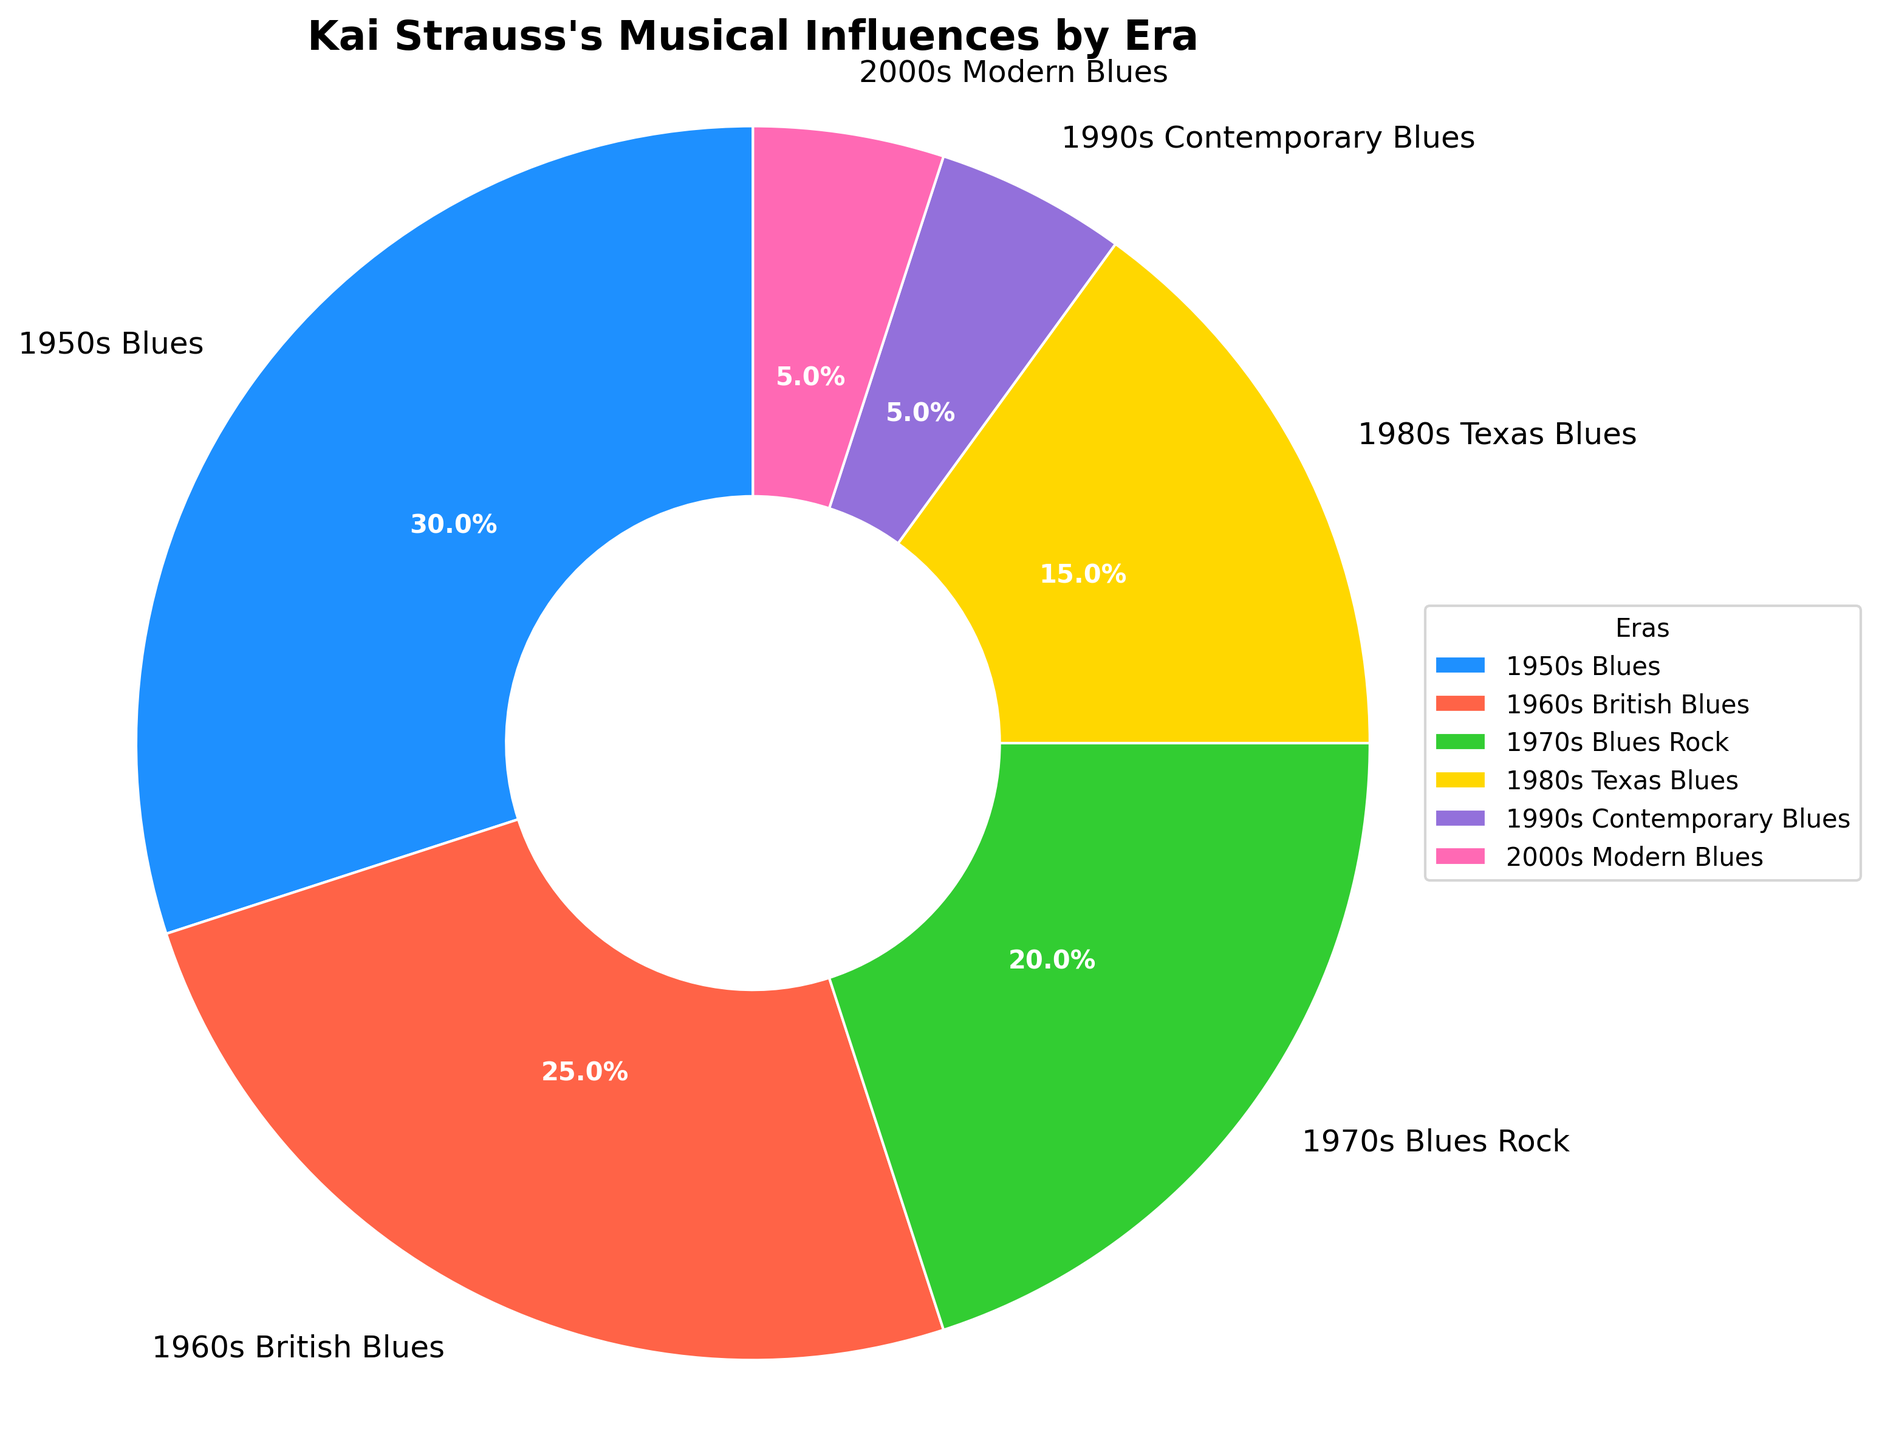What percentage of Kai Strauss's musical influences comes from the 1960s British Blues era? Based on the pie chart, the slice labeled "1960s British Blues" shows a percentage of the influences. This value represents the portion of Kai Strauss's musical influences that come from this era.
Answer: 25% How do the percentages of Kai Strauss's influences from the 1970s Blues Rock and 1980s Texas Blues compare? To answer this, we compare the labeled slices for the "1970s Blues Rock" and "1980s Texas Blues" on the chart. The percentage for the 1970s Blues Rock is 20%, while the 1980s Texas Blues is 15%.
Answer: 1970s Blues Rock (20%) is greater than 1980s Texas Blues (15%) What is the combined percentage of Kai Strauss's musical influences from the 1990s Contemporary Blues and the 2000s Modern Blues eras? To find the combined percentage, we sum the percentages labeled for "1990s Contemporary Blues" (5%) and "2000s Modern Blues" (5%). Adding these gives 5% + 5% = 10%.
Answer: 10% Which era contributes the largest percentage to Kai Strauss's musical influences, and what is that percentage? The largest slice on the pie chart is labeled "1950s Blues," which shows the highest percentage.
Answer: 1950s Blues at 30% How much larger is the percentage of musical influences from the 1960s British Blues compared to the 1990s Contemporary Blues? We calculate the difference between the two percentages: 25% (1960s British Blues) - 5% (1990s Contemporary Blues) = 20%.
Answer: 20% Which era contributes the smallest percentage to Kai Strauss's musical influences, and what is that percentage? The smallest slice on the pie chart is labeled "2000s Modern Blues," and it shares this percentage with the "1990s Contemporary Blues."
Answer: 5% (2000s Modern Blues and 1990s Contemporary Blues) What color represents the era with the highest percentage, and what is the name of that era? The era with the highest percentage is the "1950s Blues" at 30%, represented by the color blue.
Answer: Blue, 1950s Blues If you combine the influences from the 1950s Blues and 1970s Blues Rock, what will be the total percentage? To find the combined total, we add 30% (1950s Blues) and 20% (1970s Blues Rock). This gives 30% + 20% = 50%.
Answer: 50% What percentage difference is there between the musical influences from the 1960s British Blues and the 1980s Texas Blues? To find the difference, subtract the percentage of 1980s Texas Blues from the 1960s British Blues. So, 25% - 15% = 10%.
Answer: 10% What percentage of Kai Strauss's influences come from eras prior to the 1970s? Summing the percentages of the "1950s Blues" (30%) and the "1960s British Blues" (25%) gives us 30% + 25% = 55%.
Answer: 55% 